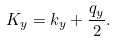Convert formula to latex. <formula><loc_0><loc_0><loc_500><loc_500>K _ { y } = k _ { y } + \frac { q _ { y } } { 2 } .</formula> 